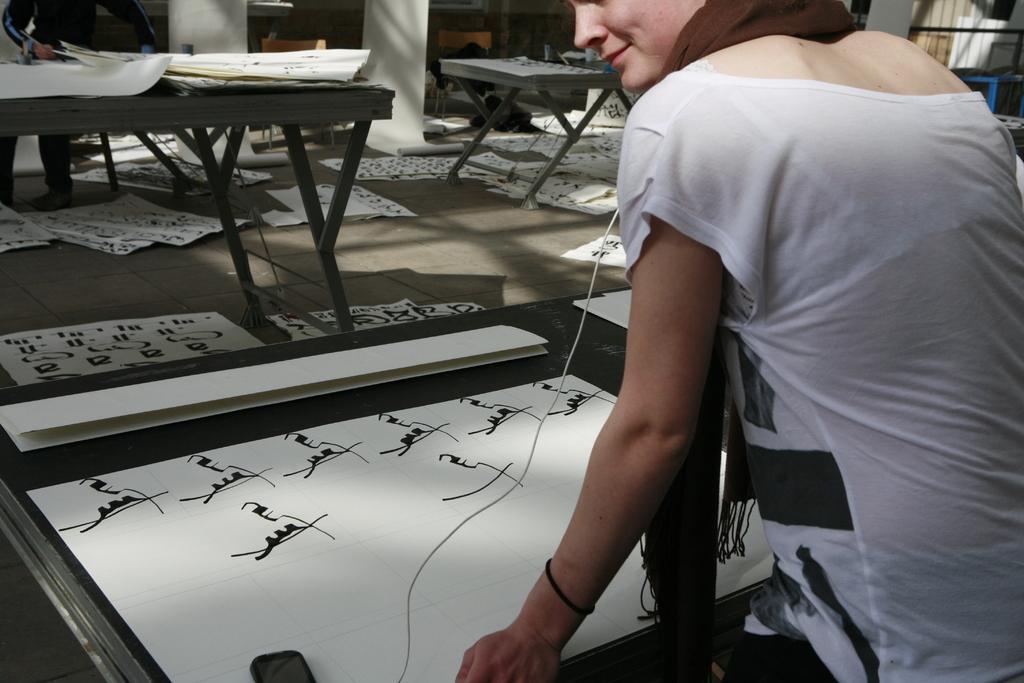Could you give a brief overview of what you see in this image? The image is taken in the room. On the right there is lady standing before her there is a table and papers placed on the table. In the background there is a wall and a man standing. We can see some papers placed on the floor. 